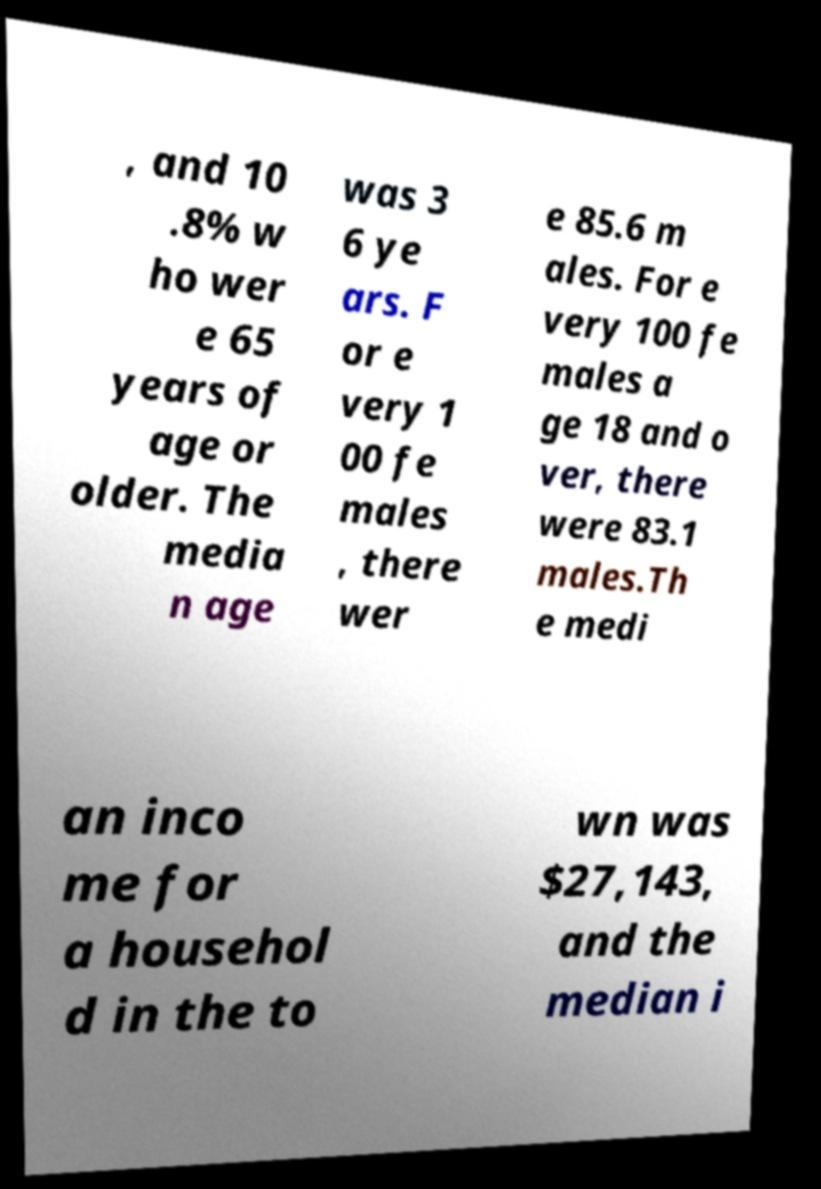Could you assist in decoding the text presented in this image and type it out clearly? , and 10 .8% w ho wer e 65 years of age or older. The media n age was 3 6 ye ars. F or e very 1 00 fe males , there wer e 85.6 m ales. For e very 100 fe males a ge 18 and o ver, there were 83.1 males.Th e medi an inco me for a househol d in the to wn was $27,143, and the median i 